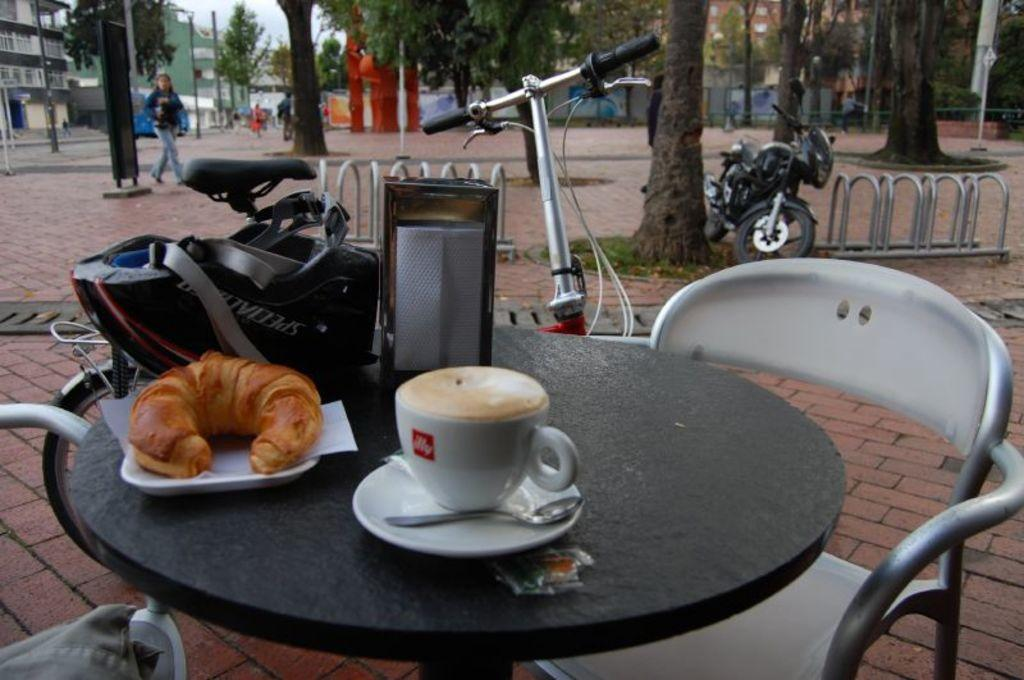What is placed in the street in the image? There is a table in the street in the image. What is on the table? Food items are kept on the table. What can be seen in the background of the image? There are trees and a bike visible in the background. Are there any people in the image? Yes, there is a lady in the background. What type of book is the frog reading on the table? There is no frog or book present in the image. What type of car is parked near the table in the image? There is no car visible in the image; only a table, food items, trees, a bike, and a lady are present. 